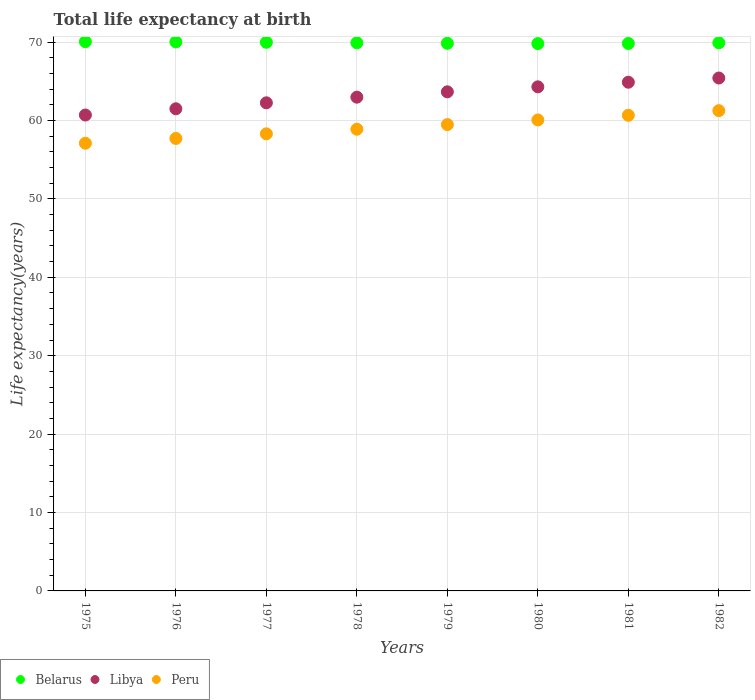How many different coloured dotlines are there?
Offer a terse response. 3. What is the life expectancy at birth in in Libya in 1980?
Give a very brief answer. 64.29. Across all years, what is the maximum life expectancy at birth in in Belarus?
Ensure brevity in your answer.  70.05. Across all years, what is the minimum life expectancy at birth in in Peru?
Provide a succinct answer. 57.1. In which year was the life expectancy at birth in in Libya minimum?
Ensure brevity in your answer.  1975. What is the total life expectancy at birth in in Peru in the graph?
Your response must be concise. 473.42. What is the difference between the life expectancy at birth in in Belarus in 1976 and that in 1982?
Your answer should be very brief. 0.11. What is the difference between the life expectancy at birth in in Peru in 1981 and the life expectancy at birth in in Libya in 1977?
Offer a terse response. -1.59. What is the average life expectancy at birth in in Peru per year?
Provide a succinct answer. 59.18. In the year 1976, what is the difference between the life expectancy at birth in in Libya and life expectancy at birth in in Peru?
Ensure brevity in your answer.  3.78. In how many years, is the life expectancy at birth in in Peru greater than 60 years?
Keep it short and to the point. 3. What is the ratio of the life expectancy at birth in in Peru in 1977 to that in 1981?
Provide a short and direct response. 0.96. Is the life expectancy at birth in in Libya in 1976 less than that in 1978?
Ensure brevity in your answer.  Yes. What is the difference between the highest and the second highest life expectancy at birth in in Peru?
Your answer should be compact. 0.59. What is the difference between the highest and the lowest life expectancy at birth in in Libya?
Provide a short and direct response. 4.72. In how many years, is the life expectancy at birth in in Libya greater than the average life expectancy at birth in in Libya taken over all years?
Ensure brevity in your answer.  4. Is it the case that in every year, the sum of the life expectancy at birth in in Belarus and life expectancy at birth in in Peru  is greater than the life expectancy at birth in in Libya?
Ensure brevity in your answer.  Yes. Does the life expectancy at birth in in Peru monotonically increase over the years?
Give a very brief answer. Yes. Is the life expectancy at birth in in Belarus strictly less than the life expectancy at birth in in Peru over the years?
Offer a very short reply. No. How many dotlines are there?
Provide a succinct answer. 3. What is the difference between two consecutive major ticks on the Y-axis?
Your answer should be very brief. 10. Does the graph contain any zero values?
Ensure brevity in your answer.  No. Where does the legend appear in the graph?
Give a very brief answer. Bottom left. What is the title of the graph?
Make the answer very short. Total life expectancy at birth. Does "Chile" appear as one of the legend labels in the graph?
Your answer should be compact. No. What is the label or title of the Y-axis?
Make the answer very short. Life expectancy(years). What is the Life expectancy(years) in Belarus in 1975?
Provide a short and direct response. 70.05. What is the Life expectancy(years) in Libya in 1975?
Offer a terse response. 60.69. What is the Life expectancy(years) of Peru in 1975?
Your response must be concise. 57.1. What is the Life expectancy(years) of Belarus in 1976?
Give a very brief answer. 70.02. What is the Life expectancy(years) in Libya in 1976?
Your response must be concise. 61.49. What is the Life expectancy(years) in Peru in 1976?
Your answer should be compact. 57.7. What is the Life expectancy(years) in Belarus in 1977?
Provide a short and direct response. 69.97. What is the Life expectancy(years) in Libya in 1977?
Keep it short and to the point. 62.25. What is the Life expectancy(years) in Peru in 1977?
Offer a very short reply. 58.29. What is the Life expectancy(years) of Belarus in 1978?
Offer a terse response. 69.91. What is the Life expectancy(years) of Libya in 1978?
Make the answer very short. 62.97. What is the Life expectancy(years) of Peru in 1978?
Provide a short and direct response. 58.88. What is the Life expectancy(years) of Belarus in 1979?
Offer a very short reply. 69.84. What is the Life expectancy(years) of Libya in 1979?
Give a very brief answer. 63.65. What is the Life expectancy(years) of Peru in 1979?
Make the answer very short. 59.47. What is the Life expectancy(years) in Belarus in 1980?
Your response must be concise. 69.8. What is the Life expectancy(years) of Libya in 1980?
Your response must be concise. 64.29. What is the Life expectancy(years) of Peru in 1980?
Provide a short and direct response. 60.06. What is the Life expectancy(years) of Belarus in 1981?
Offer a terse response. 69.82. What is the Life expectancy(years) of Libya in 1981?
Offer a terse response. 64.87. What is the Life expectancy(years) of Peru in 1981?
Your answer should be very brief. 60.66. What is the Life expectancy(years) of Belarus in 1982?
Keep it short and to the point. 69.91. What is the Life expectancy(years) of Libya in 1982?
Offer a very short reply. 65.41. What is the Life expectancy(years) in Peru in 1982?
Provide a short and direct response. 61.25. Across all years, what is the maximum Life expectancy(years) in Belarus?
Offer a terse response. 70.05. Across all years, what is the maximum Life expectancy(years) in Libya?
Provide a succinct answer. 65.41. Across all years, what is the maximum Life expectancy(years) of Peru?
Ensure brevity in your answer.  61.25. Across all years, what is the minimum Life expectancy(years) in Belarus?
Offer a very short reply. 69.8. Across all years, what is the minimum Life expectancy(years) in Libya?
Give a very brief answer. 60.69. Across all years, what is the minimum Life expectancy(years) in Peru?
Make the answer very short. 57.1. What is the total Life expectancy(years) of Belarus in the graph?
Keep it short and to the point. 559.31. What is the total Life expectancy(years) in Libya in the graph?
Give a very brief answer. 505.62. What is the total Life expectancy(years) of Peru in the graph?
Keep it short and to the point. 473.42. What is the difference between the Life expectancy(years) in Belarus in 1975 and that in 1976?
Ensure brevity in your answer.  0.03. What is the difference between the Life expectancy(years) in Libya in 1975 and that in 1976?
Your response must be concise. -0.8. What is the difference between the Life expectancy(years) of Peru in 1975 and that in 1976?
Your response must be concise. -0.61. What is the difference between the Life expectancy(years) in Belarus in 1975 and that in 1977?
Your answer should be compact. 0.08. What is the difference between the Life expectancy(years) of Libya in 1975 and that in 1977?
Offer a very short reply. -1.56. What is the difference between the Life expectancy(years) of Peru in 1975 and that in 1977?
Offer a terse response. -1.2. What is the difference between the Life expectancy(years) in Belarus in 1975 and that in 1978?
Offer a very short reply. 0.14. What is the difference between the Life expectancy(years) in Libya in 1975 and that in 1978?
Make the answer very short. -2.28. What is the difference between the Life expectancy(years) in Peru in 1975 and that in 1978?
Your answer should be very brief. -1.78. What is the difference between the Life expectancy(years) of Belarus in 1975 and that in 1979?
Keep it short and to the point. 0.21. What is the difference between the Life expectancy(years) of Libya in 1975 and that in 1979?
Give a very brief answer. -2.96. What is the difference between the Life expectancy(years) in Peru in 1975 and that in 1979?
Provide a short and direct response. -2.37. What is the difference between the Life expectancy(years) of Belarus in 1975 and that in 1980?
Keep it short and to the point. 0.25. What is the difference between the Life expectancy(years) of Libya in 1975 and that in 1980?
Give a very brief answer. -3.6. What is the difference between the Life expectancy(years) of Peru in 1975 and that in 1980?
Offer a very short reply. -2.97. What is the difference between the Life expectancy(years) in Belarus in 1975 and that in 1981?
Keep it short and to the point. 0.23. What is the difference between the Life expectancy(years) of Libya in 1975 and that in 1981?
Provide a succinct answer. -4.18. What is the difference between the Life expectancy(years) of Peru in 1975 and that in 1981?
Your response must be concise. -3.56. What is the difference between the Life expectancy(years) in Belarus in 1975 and that in 1982?
Offer a very short reply. 0.14. What is the difference between the Life expectancy(years) of Libya in 1975 and that in 1982?
Offer a terse response. -4.72. What is the difference between the Life expectancy(years) in Peru in 1975 and that in 1982?
Provide a short and direct response. -4.15. What is the difference between the Life expectancy(years) of Belarus in 1976 and that in 1977?
Keep it short and to the point. 0.05. What is the difference between the Life expectancy(years) of Libya in 1976 and that in 1977?
Your response must be concise. -0.76. What is the difference between the Life expectancy(years) of Peru in 1976 and that in 1977?
Give a very brief answer. -0.59. What is the difference between the Life expectancy(years) in Belarus in 1976 and that in 1978?
Your response must be concise. 0.11. What is the difference between the Life expectancy(years) in Libya in 1976 and that in 1978?
Your answer should be very brief. -1.48. What is the difference between the Life expectancy(years) of Peru in 1976 and that in 1978?
Your answer should be very brief. -1.18. What is the difference between the Life expectancy(years) in Belarus in 1976 and that in 1979?
Make the answer very short. 0.17. What is the difference between the Life expectancy(years) of Libya in 1976 and that in 1979?
Keep it short and to the point. -2.16. What is the difference between the Life expectancy(years) of Peru in 1976 and that in 1979?
Your answer should be compact. -1.77. What is the difference between the Life expectancy(years) of Belarus in 1976 and that in 1980?
Your response must be concise. 0.21. What is the difference between the Life expectancy(years) in Libya in 1976 and that in 1980?
Provide a succinct answer. -2.8. What is the difference between the Life expectancy(years) of Peru in 1976 and that in 1980?
Your response must be concise. -2.36. What is the difference between the Life expectancy(years) in Belarus in 1976 and that in 1981?
Offer a very short reply. 0.2. What is the difference between the Life expectancy(years) of Libya in 1976 and that in 1981?
Offer a very short reply. -3.39. What is the difference between the Life expectancy(years) in Peru in 1976 and that in 1981?
Ensure brevity in your answer.  -2.95. What is the difference between the Life expectancy(years) of Belarus in 1976 and that in 1982?
Offer a very short reply. 0.11. What is the difference between the Life expectancy(years) in Libya in 1976 and that in 1982?
Provide a short and direct response. -3.92. What is the difference between the Life expectancy(years) of Peru in 1976 and that in 1982?
Keep it short and to the point. -3.54. What is the difference between the Life expectancy(years) of Belarus in 1977 and that in 1978?
Your answer should be very brief. 0.06. What is the difference between the Life expectancy(years) of Libya in 1977 and that in 1978?
Give a very brief answer. -0.72. What is the difference between the Life expectancy(years) in Peru in 1977 and that in 1978?
Your answer should be very brief. -0.59. What is the difference between the Life expectancy(years) of Belarus in 1977 and that in 1979?
Keep it short and to the point. 0.13. What is the difference between the Life expectancy(years) of Libya in 1977 and that in 1979?
Give a very brief answer. -1.4. What is the difference between the Life expectancy(years) in Peru in 1977 and that in 1979?
Provide a succinct answer. -1.18. What is the difference between the Life expectancy(years) in Belarus in 1977 and that in 1980?
Your answer should be compact. 0.17. What is the difference between the Life expectancy(years) of Libya in 1977 and that in 1980?
Your answer should be very brief. -2.04. What is the difference between the Life expectancy(years) of Peru in 1977 and that in 1980?
Make the answer very short. -1.77. What is the difference between the Life expectancy(years) of Belarus in 1977 and that in 1981?
Keep it short and to the point. 0.15. What is the difference between the Life expectancy(years) of Libya in 1977 and that in 1981?
Your response must be concise. -2.63. What is the difference between the Life expectancy(years) in Peru in 1977 and that in 1981?
Provide a short and direct response. -2.36. What is the difference between the Life expectancy(years) of Belarus in 1977 and that in 1982?
Ensure brevity in your answer.  0.06. What is the difference between the Life expectancy(years) in Libya in 1977 and that in 1982?
Offer a very short reply. -3.16. What is the difference between the Life expectancy(years) of Peru in 1977 and that in 1982?
Your answer should be very brief. -2.96. What is the difference between the Life expectancy(years) in Belarus in 1978 and that in 1979?
Ensure brevity in your answer.  0.06. What is the difference between the Life expectancy(years) in Libya in 1978 and that in 1979?
Ensure brevity in your answer.  -0.68. What is the difference between the Life expectancy(years) in Peru in 1978 and that in 1979?
Your response must be concise. -0.59. What is the difference between the Life expectancy(years) in Belarus in 1978 and that in 1980?
Keep it short and to the point. 0.1. What is the difference between the Life expectancy(years) in Libya in 1978 and that in 1980?
Make the answer very short. -1.32. What is the difference between the Life expectancy(years) of Peru in 1978 and that in 1980?
Keep it short and to the point. -1.18. What is the difference between the Life expectancy(years) of Belarus in 1978 and that in 1981?
Keep it short and to the point. 0.09. What is the difference between the Life expectancy(years) in Libya in 1978 and that in 1981?
Your response must be concise. -1.91. What is the difference between the Life expectancy(years) of Peru in 1978 and that in 1981?
Offer a terse response. -1.78. What is the difference between the Life expectancy(years) of Belarus in 1978 and that in 1982?
Give a very brief answer. -0. What is the difference between the Life expectancy(years) in Libya in 1978 and that in 1982?
Provide a succinct answer. -2.44. What is the difference between the Life expectancy(years) in Peru in 1978 and that in 1982?
Ensure brevity in your answer.  -2.37. What is the difference between the Life expectancy(years) of Belarus in 1979 and that in 1980?
Your response must be concise. 0.04. What is the difference between the Life expectancy(years) of Libya in 1979 and that in 1980?
Offer a very short reply. -0.64. What is the difference between the Life expectancy(years) of Peru in 1979 and that in 1980?
Give a very brief answer. -0.59. What is the difference between the Life expectancy(years) in Belarus in 1979 and that in 1981?
Your answer should be compact. 0.02. What is the difference between the Life expectancy(years) in Libya in 1979 and that in 1981?
Your answer should be very brief. -1.22. What is the difference between the Life expectancy(years) of Peru in 1979 and that in 1981?
Offer a very short reply. -1.19. What is the difference between the Life expectancy(years) in Belarus in 1979 and that in 1982?
Keep it short and to the point. -0.07. What is the difference between the Life expectancy(years) of Libya in 1979 and that in 1982?
Ensure brevity in your answer.  -1.76. What is the difference between the Life expectancy(years) in Peru in 1979 and that in 1982?
Your response must be concise. -1.78. What is the difference between the Life expectancy(years) in Belarus in 1980 and that in 1981?
Keep it short and to the point. -0.02. What is the difference between the Life expectancy(years) of Libya in 1980 and that in 1981?
Offer a very short reply. -0.59. What is the difference between the Life expectancy(years) of Peru in 1980 and that in 1981?
Give a very brief answer. -0.6. What is the difference between the Life expectancy(years) in Belarus in 1980 and that in 1982?
Make the answer very short. -0.11. What is the difference between the Life expectancy(years) of Libya in 1980 and that in 1982?
Give a very brief answer. -1.12. What is the difference between the Life expectancy(years) of Peru in 1980 and that in 1982?
Give a very brief answer. -1.19. What is the difference between the Life expectancy(years) of Belarus in 1981 and that in 1982?
Make the answer very short. -0.09. What is the difference between the Life expectancy(years) in Libya in 1981 and that in 1982?
Your answer should be compact. -0.54. What is the difference between the Life expectancy(years) in Peru in 1981 and that in 1982?
Your answer should be compact. -0.59. What is the difference between the Life expectancy(years) in Belarus in 1975 and the Life expectancy(years) in Libya in 1976?
Offer a terse response. 8.56. What is the difference between the Life expectancy(years) of Belarus in 1975 and the Life expectancy(years) of Peru in 1976?
Make the answer very short. 12.34. What is the difference between the Life expectancy(years) of Libya in 1975 and the Life expectancy(years) of Peru in 1976?
Ensure brevity in your answer.  2.99. What is the difference between the Life expectancy(years) of Belarus in 1975 and the Life expectancy(years) of Libya in 1977?
Provide a short and direct response. 7.8. What is the difference between the Life expectancy(years) of Belarus in 1975 and the Life expectancy(years) of Peru in 1977?
Keep it short and to the point. 11.75. What is the difference between the Life expectancy(years) of Libya in 1975 and the Life expectancy(years) of Peru in 1977?
Ensure brevity in your answer.  2.4. What is the difference between the Life expectancy(years) in Belarus in 1975 and the Life expectancy(years) in Libya in 1978?
Make the answer very short. 7.08. What is the difference between the Life expectancy(years) of Belarus in 1975 and the Life expectancy(years) of Peru in 1978?
Keep it short and to the point. 11.17. What is the difference between the Life expectancy(years) in Libya in 1975 and the Life expectancy(years) in Peru in 1978?
Keep it short and to the point. 1.81. What is the difference between the Life expectancy(years) in Belarus in 1975 and the Life expectancy(years) in Libya in 1979?
Ensure brevity in your answer.  6.4. What is the difference between the Life expectancy(years) of Belarus in 1975 and the Life expectancy(years) of Peru in 1979?
Offer a very short reply. 10.58. What is the difference between the Life expectancy(years) in Libya in 1975 and the Life expectancy(years) in Peru in 1979?
Ensure brevity in your answer.  1.22. What is the difference between the Life expectancy(years) of Belarus in 1975 and the Life expectancy(years) of Libya in 1980?
Provide a succinct answer. 5.76. What is the difference between the Life expectancy(years) in Belarus in 1975 and the Life expectancy(years) in Peru in 1980?
Offer a very short reply. 9.98. What is the difference between the Life expectancy(years) in Libya in 1975 and the Life expectancy(years) in Peru in 1980?
Ensure brevity in your answer.  0.63. What is the difference between the Life expectancy(years) in Belarus in 1975 and the Life expectancy(years) in Libya in 1981?
Your answer should be very brief. 5.17. What is the difference between the Life expectancy(years) in Belarus in 1975 and the Life expectancy(years) in Peru in 1981?
Ensure brevity in your answer.  9.39. What is the difference between the Life expectancy(years) in Libya in 1975 and the Life expectancy(years) in Peru in 1981?
Give a very brief answer. 0.03. What is the difference between the Life expectancy(years) of Belarus in 1975 and the Life expectancy(years) of Libya in 1982?
Give a very brief answer. 4.64. What is the difference between the Life expectancy(years) in Belarus in 1975 and the Life expectancy(years) in Peru in 1982?
Ensure brevity in your answer.  8.8. What is the difference between the Life expectancy(years) of Libya in 1975 and the Life expectancy(years) of Peru in 1982?
Your response must be concise. -0.56. What is the difference between the Life expectancy(years) of Belarus in 1976 and the Life expectancy(years) of Libya in 1977?
Offer a very short reply. 7.77. What is the difference between the Life expectancy(years) in Belarus in 1976 and the Life expectancy(years) in Peru in 1977?
Provide a succinct answer. 11.72. What is the difference between the Life expectancy(years) of Libya in 1976 and the Life expectancy(years) of Peru in 1977?
Provide a short and direct response. 3.19. What is the difference between the Life expectancy(years) in Belarus in 1976 and the Life expectancy(years) in Libya in 1978?
Your response must be concise. 7.05. What is the difference between the Life expectancy(years) in Belarus in 1976 and the Life expectancy(years) in Peru in 1978?
Provide a succinct answer. 11.13. What is the difference between the Life expectancy(years) of Libya in 1976 and the Life expectancy(years) of Peru in 1978?
Your answer should be very brief. 2.61. What is the difference between the Life expectancy(years) in Belarus in 1976 and the Life expectancy(years) in Libya in 1979?
Make the answer very short. 6.37. What is the difference between the Life expectancy(years) of Belarus in 1976 and the Life expectancy(years) of Peru in 1979?
Ensure brevity in your answer.  10.55. What is the difference between the Life expectancy(years) of Libya in 1976 and the Life expectancy(years) of Peru in 1979?
Make the answer very short. 2.02. What is the difference between the Life expectancy(years) in Belarus in 1976 and the Life expectancy(years) in Libya in 1980?
Offer a terse response. 5.73. What is the difference between the Life expectancy(years) in Belarus in 1976 and the Life expectancy(years) in Peru in 1980?
Your answer should be compact. 9.95. What is the difference between the Life expectancy(years) of Libya in 1976 and the Life expectancy(years) of Peru in 1980?
Give a very brief answer. 1.43. What is the difference between the Life expectancy(years) of Belarus in 1976 and the Life expectancy(years) of Libya in 1981?
Keep it short and to the point. 5.14. What is the difference between the Life expectancy(years) of Belarus in 1976 and the Life expectancy(years) of Peru in 1981?
Provide a short and direct response. 9.36. What is the difference between the Life expectancy(years) in Libya in 1976 and the Life expectancy(years) in Peru in 1981?
Your answer should be very brief. 0.83. What is the difference between the Life expectancy(years) in Belarus in 1976 and the Life expectancy(years) in Libya in 1982?
Your response must be concise. 4.61. What is the difference between the Life expectancy(years) in Belarus in 1976 and the Life expectancy(years) in Peru in 1982?
Ensure brevity in your answer.  8.77. What is the difference between the Life expectancy(years) of Libya in 1976 and the Life expectancy(years) of Peru in 1982?
Your response must be concise. 0.24. What is the difference between the Life expectancy(years) in Belarus in 1977 and the Life expectancy(years) in Libya in 1978?
Ensure brevity in your answer.  7. What is the difference between the Life expectancy(years) of Belarus in 1977 and the Life expectancy(years) of Peru in 1978?
Ensure brevity in your answer.  11.09. What is the difference between the Life expectancy(years) of Libya in 1977 and the Life expectancy(years) of Peru in 1978?
Keep it short and to the point. 3.37. What is the difference between the Life expectancy(years) in Belarus in 1977 and the Life expectancy(years) in Libya in 1979?
Your response must be concise. 6.32. What is the difference between the Life expectancy(years) in Belarus in 1977 and the Life expectancy(years) in Peru in 1979?
Offer a very short reply. 10.5. What is the difference between the Life expectancy(years) in Libya in 1977 and the Life expectancy(years) in Peru in 1979?
Keep it short and to the point. 2.78. What is the difference between the Life expectancy(years) in Belarus in 1977 and the Life expectancy(years) in Libya in 1980?
Provide a short and direct response. 5.68. What is the difference between the Life expectancy(years) in Belarus in 1977 and the Life expectancy(years) in Peru in 1980?
Your answer should be compact. 9.9. What is the difference between the Life expectancy(years) in Libya in 1977 and the Life expectancy(years) in Peru in 1980?
Your answer should be compact. 2.18. What is the difference between the Life expectancy(years) in Belarus in 1977 and the Life expectancy(years) in Libya in 1981?
Your answer should be compact. 5.09. What is the difference between the Life expectancy(years) in Belarus in 1977 and the Life expectancy(years) in Peru in 1981?
Ensure brevity in your answer.  9.31. What is the difference between the Life expectancy(years) of Libya in 1977 and the Life expectancy(years) of Peru in 1981?
Provide a short and direct response. 1.59. What is the difference between the Life expectancy(years) of Belarus in 1977 and the Life expectancy(years) of Libya in 1982?
Offer a terse response. 4.56. What is the difference between the Life expectancy(years) of Belarus in 1977 and the Life expectancy(years) of Peru in 1982?
Provide a short and direct response. 8.72. What is the difference between the Life expectancy(years) of Libya in 1977 and the Life expectancy(years) of Peru in 1982?
Offer a very short reply. 1. What is the difference between the Life expectancy(years) in Belarus in 1978 and the Life expectancy(years) in Libya in 1979?
Give a very brief answer. 6.26. What is the difference between the Life expectancy(years) of Belarus in 1978 and the Life expectancy(years) of Peru in 1979?
Provide a succinct answer. 10.44. What is the difference between the Life expectancy(years) in Libya in 1978 and the Life expectancy(years) in Peru in 1979?
Your answer should be very brief. 3.5. What is the difference between the Life expectancy(years) in Belarus in 1978 and the Life expectancy(years) in Libya in 1980?
Your answer should be very brief. 5.62. What is the difference between the Life expectancy(years) in Belarus in 1978 and the Life expectancy(years) in Peru in 1980?
Ensure brevity in your answer.  9.84. What is the difference between the Life expectancy(years) of Libya in 1978 and the Life expectancy(years) of Peru in 1980?
Offer a very short reply. 2.9. What is the difference between the Life expectancy(years) in Belarus in 1978 and the Life expectancy(years) in Libya in 1981?
Provide a succinct answer. 5.03. What is the difference between the Life expectancy(years) of Belarus in 1978 and the Life expectancy(years) of Peru in 1981?
Offer a very short reply. 9.25. What is the difference between the Life expectancy(years) in Libya in 1978 and the Life expectancy(years) in Peru in 1981?
Provide a short and direct response. 2.31. What is the difference between the Life expectancy(years) in Belarus in 1978 and the Life expectancy(years) in Libya in 1982?
Offer a terse response. 4.5. What is the difference between the Life expectancy(years) of Belarus in 1978 and the Life expectancy(years) of Peru in 1982?
Offer a very short reply. 8.66. What is the difference between the Life expectancy(years) of Libya in 1978 and the Life expectancy(years) of Peru in 1982?
Give a very brief answer. 1.72. What is the difference between the Life expectancy(years) in Belarus in 1979 and the Life expectancy(years) in Libya in 1980?
Make the answer very short. 5.55. What is the difference between the Life expectancy(years) of Belarus in 1979 and the Life expectancy(years) of Peru in 1980?
Your answer should be very brief. 9.78. What is the difference between the Life expectancy(years) in Libya in 1979 and the Life expectancy(years) in Peru in 1980?
Keep it short and to the point. 3.59. What is the difference between the Life expectancy(years) in Belarus in 1979 and the Life expectancy(years) in Libya in 1981?
Your answer should be very brief. 4.97. What is the difference between the Life expectancy(years) in Belarus in 1979 and the Life expectancy(years) in Peru in 1981?
Provide a short and direct response. 9.18. What is the difference between the Life expectancy(years) of Libya in 1979 and the Life expectancy(years) of Peru in 1981?
Your response must be concise. 2.99. What is the difference between the Life expectancy(years) in Belarus in 1979 and the Life expectancy(years) in Libya in 1982?
Offer a terse response. 4.43. What is the difference between the Life expectancy(years) of Belarus in 1979 and the Life expectancy(years) of Peru in 1982?
Provide a succinct answer. 8.59. What is the difference between the Life expectancy(years) in Libya in 1979 and the Life expectancy(years) in Peru in 1982?
Provide a succinct answer. 2.4. What is the difference between the Life expectancy(years) in Belarus in 1980 and the Life expectancy(years) in Libya in 1981?
Offer a very short reply. 4.93. What is the difference between the Life expectancy(years) of Belarus in 1980 and the Life expectancy(years) of Peru in 1981?
Ensure brevity in your answer.  9.14. What is the difference between the Life expectancy(years) in Libya in 1980 and the Life expectancy(years) in Peru in 1981?
Keep it short and to the point. 3.63. What is the difference between the Life expectancy(years) in Belarus in 1980 and the Life expectancy(years) in Libya in 1982?
Give a very brief answer. 4.39. What is the difference between the Life expectancy(years) of Belarus in 1980 and the Life expectancy(years) of Peru in 1982?
Offer a terse response. 8.55. What is the difference between the Life expectancy(years) of Libya in 1980 and the Life expectancy(years) of Peru in 1982?
Give a very brief answer. 3.04. What is the difference between the Life expectancy(years) in Belarus in 1981 and the Life expectancy(years) in Libya in 1982?
Ensure brevity in your answer.  4.41. What is the difference between the Life expectancy(years) in Belarus in 1981 and the Life expectancy(years) in Peru in 1982?
Your answer should be very brief. 8.57. What is the difference between the Life expectancy(years) of Libya in 1981 and the Life expectancy(years) of Peru in 1982?
Keep it short and to the point. 3.62. What is the average Life expectancy(years) of Belarus per year?
Give a very brief answer. 69.91. What is the average Life expectancy(years) of Libya per year?
Offer a very short reply. 63.2. What is the average Life expectancy(years) in Peru per year?
Keep it short and to the point. 59.18. In the year 1975, what is the difference between the Life expectancy(years) in Belarus and Life expectancy(years) in Libya?
Offer a terse response. 9.36. In the year 1975, what is the difference between the Life expectancy(years) in Belarus and Life expectancy(years) in Peru?
Make the answer very short. 12.95. In the year 1975, what is the difference between the Life expectancy(years) in Libya and Life expectancy(years) in Peru?
Your answer should be very brief. 3.59. In the year 1976, what is the difference between the Life expectancy(years) of Belarus and Life expectancy(years) of Libya?
Ensure brevity in your answer.  8.53. In the year 1976, what is the difference between the Life expectancy(years) in Belarus and Life expectancy(years) in Peru?
Keep it short and to the point. 12.31. In the year 1976, what is the difference between the Life expectancy(years) of Libya and Life expectancy(years) of Peru?
Offer a very short reply. 3.78. In the year 1977, what is the difference between the Life expectancy(years) in Belarus and Life expectancy(years) in Libya?
Ensure brevity in your answer.  7.72. In the year 1977, what is the difference between the Life expectancy(years) of Belarus and Life expectancy(years) of Peru?
Offer a terse response. 11.67. In the year 1977, what is the difference between the Life expectancy(years) of Libya and Life expectancy(years) of Peru?
Keep it short and to the point. 3.95. In the year 1978, what is the difference between the Life expectancy(years) in Belarus and Life expectancy(years) in Libya?
Offer a terse response. 6.94. In the year 1978, what is the difference between the Life expectancy(years) of Belarus and Life expectancy(years) of Peru?
Your response must be concise. 11.03. In the year 1978, what is the difference between the Life expectancy(years) of Libya and Life expectancy(years) of Peru?
Provide a short and direct response. 4.09. In the year 1979, what is the difference between the Life expectancy(years) of Belarus and Life expectancy(years) of Libya?
Offer a terse response. 6.19. In the year 1979, what is the difference between the Life expectancy(years) in Belarus and Life expectancy(years) in Peru?
Ensure brevity in your answer.  10.37. In the year 1979, what is the difference between the Life expectancy(years) in Libya and Life expectancy(years) in Peru?
Keep it short and to the point. 4.18. In the year 1980, what is the difference between the Life expectancy(years) in Belarus and Life expectancy(years) in Libya?
Offer a terse response. 5.52. In the year 1980, what is the difference between the Life expectancy(years) in Belarus and Life expectancy(years) in Peru?
Your answer should be compact. 9.74. In the year 1980, what is the difference between the Life expectancy(years) of Libya and Life expectancy(years) of Peru?
Keep it short and to the point. 4.22. In the year 1981, what is the difference between the Life expectancy(years) of Belarus and Life expectancy(years) of Libya?
Your answer should be very brief. 4.95. In the year 1981, what is the difference between the Life expectancy(years) of Belarus and Life expectancy(years) of Peru?
Ensure brevity in your answer.  9.16. In the year 1981, what is the difference between the Life expectancy(years) of Libya and Life expectancy(years) of Peru?
Keep it short and to the point. 4.22. In the year 1982, what is the difference between the Life expectancy(years) of Belarus and Life expectancy(years) of Libya?
Offer a very short reply. 4.5. In the year 1982, what is the difference between the Life expectancy(years) in Belarus and Life expectancy(years) in Peru?
Give a very brief answer. 8.66. In the year 1982, what is the difference between the Life expectancy(years) of Libya and Life expectancy(years) of Peru?
Offer a very short reply. 4.16. What is the ratio of the Life expectancy(years) of Libya in 1975 to that in 1976?
Ensure brevity in your answer.  0.99. What is the ratio of the Life expectancy(years) in Peru in 1975 to that in 1976?
Your answer should be compact. 0.99. What is the ratio of the Life expectancy(years) of Libya in 1975 to that in 1977?
Your response must be concise. 0.97. What is the ratio of the Life expectancy(years) of Peru in 1975 to that in 1977?
Your response must be concise. 0.98. What is the ratio of the Life expectancy(years) of Libya in 1975 to that in 1978?
Ensure brevity in your answer.  0.96. What is the ratio of the Life expectancy(years) in Peru in 1975 to that in 1978?
Your answer should be compact. 0.97. What is the ratio of the Life expectancy(years) of Libya in 1975 to that in 1979?
Offer a terse response. 0.95. What is the ratio of the Life expectancy(years) of Peru in 1975 to that in 1979?
Offer a very short reply. 0.96. What is the ratio of the Life expectancy(years) in Libya in 1975 to that in 1980?
Your response must be concise. 0.94. What is the ratio of the Life expectancy(years) in Peru in 1975 to that in 1980?
Your answer should be very brief. 0.95. What is the ratio of the Life expectancy(years) of Libya in 1975 to that in 1981?
Provide a succinct answer. 0.94. What is the ratio of the Life expectancy(years) of Peru in 1975 to that in 1981?
Make the answer very short. 0.94. What is the ratio of the Life expectancy(years) of Libya in 1975 to that in 1982?
Your answer should be compact. 0.93. What is the ratio of the Life expectancy(years) of Peru in 1975 to that in 1982?
Provide a succinct answer. 0.93. What is the ratio of the Life expectancy(years) in Libya in 1976 to that in 1978?
Offer a very short reply. 0.98. What is the ratio of the Life expectancy(years) of Peru in 1976 to that in 1978?
Give a very brief answer. 0.98. What is the ratio of the Life expectancy(years) of Libya in 1976 to that in 1979?
Your answer should be very brief. 0.97. What is the ratio of the Life expectancy(years) in Peru in 1976 to that in 1979?
Offer a very short reply. 0.97. What is the ratio of the Life expectancy(years) in Libya in 1976 to that in 1980?
Provide a short and direct response. 0.96. What is the ratio of the Life expectancy(years) of Peru in 1976 to that in 1980?
Your answer should be compact. 0.96. What is the ratio of the Life expectancy(years) of Libya in 1976 to that in 1981?
Your answer should be compact. 0.95. What is the ratio of the Life expectancy(years) in Peru in 1976 to that in 1981?
Ensure brevity in your answer.  0.95. What is the ratio of the Life expectancy(years) in Libya in 1976 to that in 1982?
Make the answer very short. 0.94. What is the ratio of the Life expectancy(years) in Peru in 1976 to that in 1982?
Ensure brevity in your answer.  0.94. What is the ratio of the Life expectancy(years) in Belarus in 1977 to that in 1978?
Your response must be concise. 1. What is the ratio of the Life expectancy(years) in Peru in 1977 to that in 1978?
Your answer should be very brief. 0.99. What is the ratio of the Life expectancy(years) in Peru in 1977 to that in 1979?
Your answer should be very brief. 0.98. What is the ratio of the Life expectancy(years) in Libya in 1977 to that in 1980?
Offer a very short reply. 0.97. What is the ratio of the Life expectancy(years) in Peru in 1977 to that in 1980?
Provide a succinct answer. 0.97. What is the ratio of the Life expectancy(years) in Libya in 1977 to that in 1981?
Your answer should be very brief. 0.96. What is the ratio of the Life expectancy(years) in Libya in 1977 to that in 1982?
Offer a very short reply. 0.95. What is the ratio of the Life expectancy(years) in Peru in 1977 to that in 1982?
Give a very brief answer. 0.95. What is the ratio of the Life expectancy(years) in Libya in 1978 to that in 1979?
Provide a short and direct response. 0.99. What is the ratio of the Life expectancy(years) in Libya in 1978 to that in 1980?
Make the answer very short. 0.98. What is the ratio of the Life expectancy(years) of Peru in 1978 to that in 1980?
Offer a very short reply. 0.98. What is the ratio of the Life expectancy(years) of Belarus in 1978 to that in 1981?
Ensure brevity in your answer.  1. What is the ratio of the Life expectancy(years) in Libya in 1978 to that in 1981?
Make the answer very short. 0.97. What is the ratio of the Life expectancy(years) of Peru in 1978 to that in 1981?
Your response must be concise. 0.97. What is the ratio of the Life expectancy(years) of Libya in 1978 to that in 1982?
Offer a terse response. 0.96. What is the ratio of the Life expectancy(years) in Peru in 1978 to that in 1982?
Offer a terse response. 0.96. What is the ratio of the Life expectancy(years) in Belarus in 1979 to that in 1980?
Make the answer very short. 1. What is the ratio of the Life expectancy(years) of Libya in 1979 to that in 1980?
Provide a succinct answer. 0.99. What is the ratio of the Life expectancy(years) in Peru in 1979 to that in 1980?
Keep it short and to the point. 0.99. What is the ratio of the Life expectancy(years) of Libya in 1979 to that in 1981?
Provide a short and direct response. 0.98. What is the ratio of the Life expectancy(years) of Peru in 1979 to that in 1981?
Your answer should be compact. 0.98. What is the ratio of the Life expectancy(years) of Belarus in 1979 to that in 1982?
Keep it short and to the point. 1. What is the ratio of the Life expectancy(years) of Libya in 1979 to that in 1982?
Keep it short and to the point. 0.97. What is the ratio of the Life expectancy(years) in Peru in 1979 to that in 1982?
Provide a short and direct response. 0.97. What is the ratio of the Life expectancy(years) of Libya in 1980 to that in 1981?
Offer a very short reply. 0.99. What is the ratio of the Life expectancy(years) of Peru in 1980 to that in 1981?
Ensure brevity in your answer.  0.99. What is the ratio of the Life expectancy(years) in Belarus in 1980 to that in 1982?
Offer a very short reply. 1. What is the ratio of the Life expectancy(years) of Libya in 1980 to that in 1982?
Provide a succinct answer. 0.98. What is the ratio of the Life expectancy(years) of Peru in 1980 to that in 1982?
Ensure brevity in your answer.  0.98. What is the ratio of the Life expectancy(years) of Belarus in 1981 to that in 1982?
Give a very brief answer. 1. What is the ratio of the Life expectancy(years) of Libya in 1981 to that in 1982?
Keep it short and to the point. 0.99. What is the difference between the highest and the second highest Life expectancy(years) in Belarus?
Your response must be concise. 0.03. What is the difference between the highest and the second highest Life expectancy(years) in Libya?
Your response must be concise. 0.54. What is the difference between the highest and the second highest Life expectancy(years) in Peru?
Your response must be concise. 0.59. What is the difference between the highest and the lowest Life expectancy(years) in Belarus?
Keep it short and to the point. 0.25. What is the difference between the highest and the lowest Life expectancy(years) of Libya?
Provide a short and direct response. 4.72. What is the difference between the highest and the lowest Life expectancy(years) in Peru?
Keep it short and to the point. 4.15. 